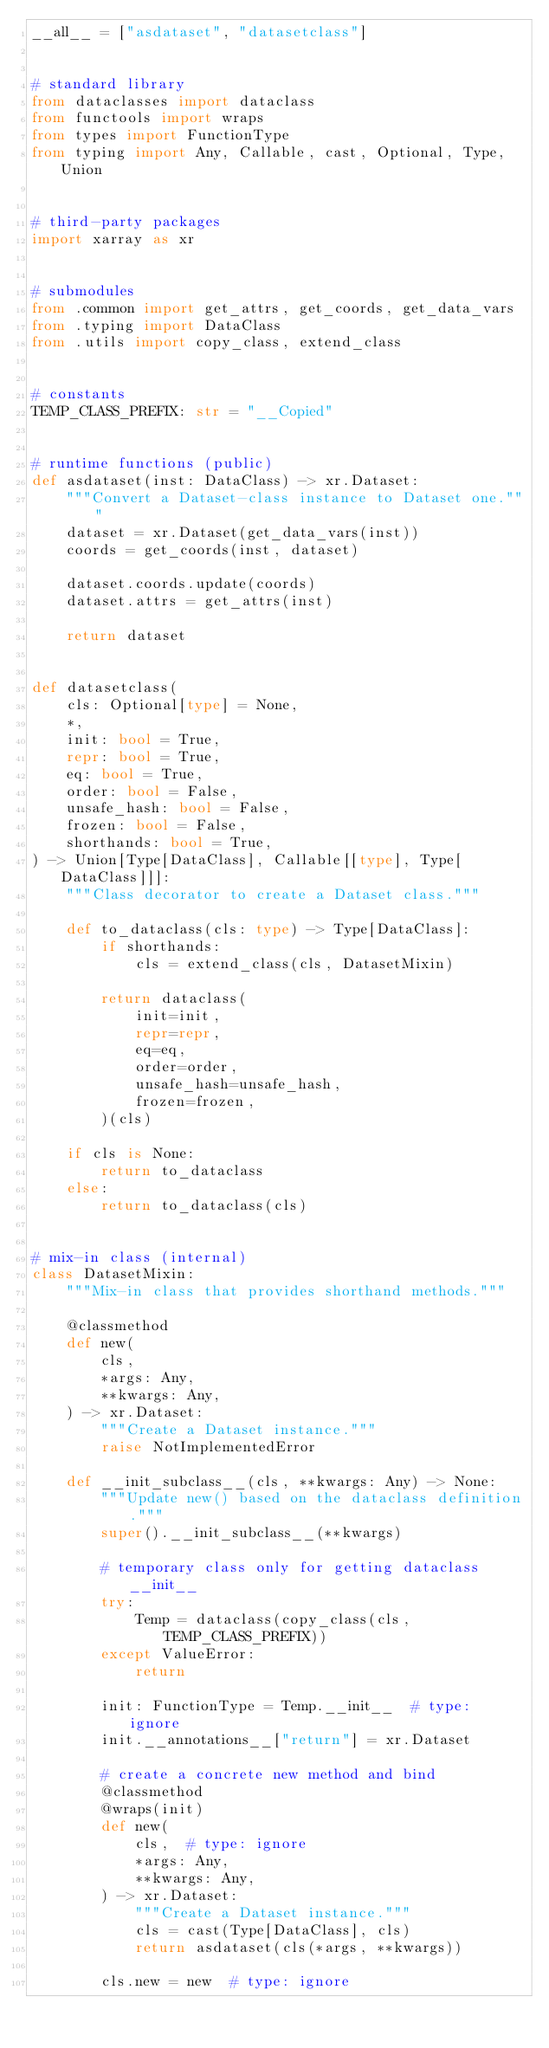Convert code to text. <code><loc_0><loc_0><loc_500><loc_500><_Python_>__all__ = ["asdataset", "datasetclass"]


# standard library
from dataclasses import dataclass
from functools import wraps
from types import FunctionType
from typing import Any, Callable, cast, Optional, Type, Union


# third-party packages
import xarray as xr


# submodules
from .common import get_attrs, get_coords, get_data_vars
from .typing import DataClass
from .utils import copy_class, extend_class


# constants
TEMP_CLASS_PREFIX: str = "__Copied"


# runtime functions (public)
def asdataset(inst: DataClass) -> xr.Dataset:
    """Convert a Dataset-class instance to Dataset one."""
    dataset = xr.Dataset(get_data_vars(inst))
    coords = get_coords(inst, dataset)

    dataset.coords.update(coords)
    dataset.attrs = get_attrs(inst)

    return dataset


def datasetclass(
    cls: Optional[type] = None,
    *,
    init: bool = True,
    repr: bool = True,
    eq: bool = True,
    order: bool = False,
    unsafe_hash: bool = False,
    frozen: bool = False,
    shorthands: bool = True,
) -> Union[Type[DataClass], Callable[[type], Type[DataClass]]]:
    """Class decorator to create a Dataset class."""

    def to_dataclass(cls: type) -> Type[DataClass]:
        if shorthands:
            cls = extend_class(cls, DatasetMixin)

        return dataclass(
            init=init,
            repr=repr,
            eq=eq,
            order=order,
            unsafe_hash=unsafe_hash,
            frozen=frozen,
        )(cls)

    if cls is None:
        return to_dataclass
    else:
        return to_dataclass(cls)


# mix-in class (internal)
class DatasetMixin:
    """Mix-in class that provides shorthand methods."""

    @classmethod
    def new(
        cls,
        *args: Any,
        **kwargs: Any,
    ) -> xr.Dataset:
        """Create a Dataset instance."""
        raise NotImplementedError

    def __init_subclass__(cls, **kwargs: Any) -> None:
        """Update new() based on the dataclass definition."""
        super().__init_subclass__(**kwargs)

        # temporary class only for getting dataclass __init__
        try:
            Temp = dataclass(copy_class(cls, TEMP_CLASS_PREFIX))
        except ValueError:
            return

        init: FunctionType = Temp.__init__  # type: ignore
        init.__annotations__["return"] = xr.Dataset

        # create a concrete new method and bind
        @classmethod
        @wraps(init)
        def new(
            cls,  # type: ignore
            *args: Any,
            **kwargs: Any,
        ) -> xr.Dataset:
            """Create a Dataset instance."""
            cls = cast(Type[DataClass], cls)
            return asdataset(cls(*args, **kwargs))

        cls.new = new  # type: ignore
</code> 